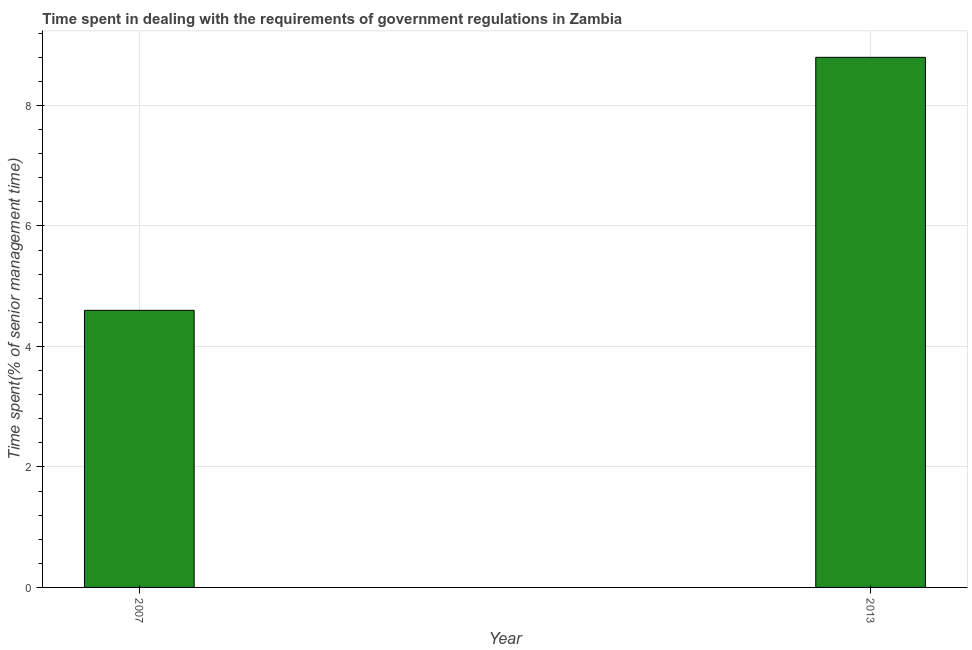What is the title of the graph?
Provide a short and direct response. Time spent in dealing with the requirements of government regulations in Zambia. What is the label or title of the Y-axis?
Provide a succinct answer. Time spent(% of senior management time). What is the time spent in dealing with government regulations in 2013?
Your answer should be very brief. 8.8. Across all years, what is the minimum time spent in dealing with government regulations?
Offer a very short reply. 4.6. In which year was the time spent in dealing with government regulations maximum?
Your answer should be very brief. 2013. What is the difference between the time spent in dealing with government regulations in 2007 and 2013?
Your answer should be compact. -4.2. What is the average time spent in dealing with government regulations per year?
Give a very brief answer. 6.7. Do a majority of the years between 2007 and 2013 (inclusive) have time spent in dealing with government regulations greater than 4.4 %?
Offer a terse response. Yes. What is the ratio of the time spent in dealing with government regulations in 2007 to that in 2013?
Ensure brevity in your answer.  0.52. In how many years, is the time spent in dealing with government regulations greater than the average time spent in dealing with government regulations taken over all years?
Give a very brief answer. 1. How many bars are there?
Your answer should be compact. 2. How many years are there in the graph?
Give a very brief answer. 2. What is the difference between two consecutive major ticks on the Y-axis?
Keep it short and to the point. 2. What is the Time spent(% of senior management time) of 2013?
Make the answer very short. 8.8. What is the ratio of the Time spent(% of senior management time) in 2007 to that in 2013?
Provide a short and direct response. 0.52. 